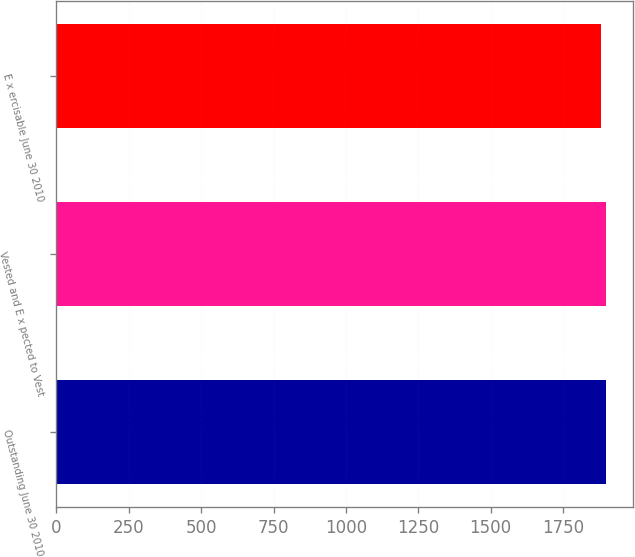<chart> <loc_0><loc_0><loc_500><loc_500><bar_chart><fcel>Outstanding June 30 2010<fcel>Vested and E x pected to Vest<fcel>E x ercisable June 30 2010<nl><fcel>1897<fcel>1898.5<fcel>1882<nl></chart> 